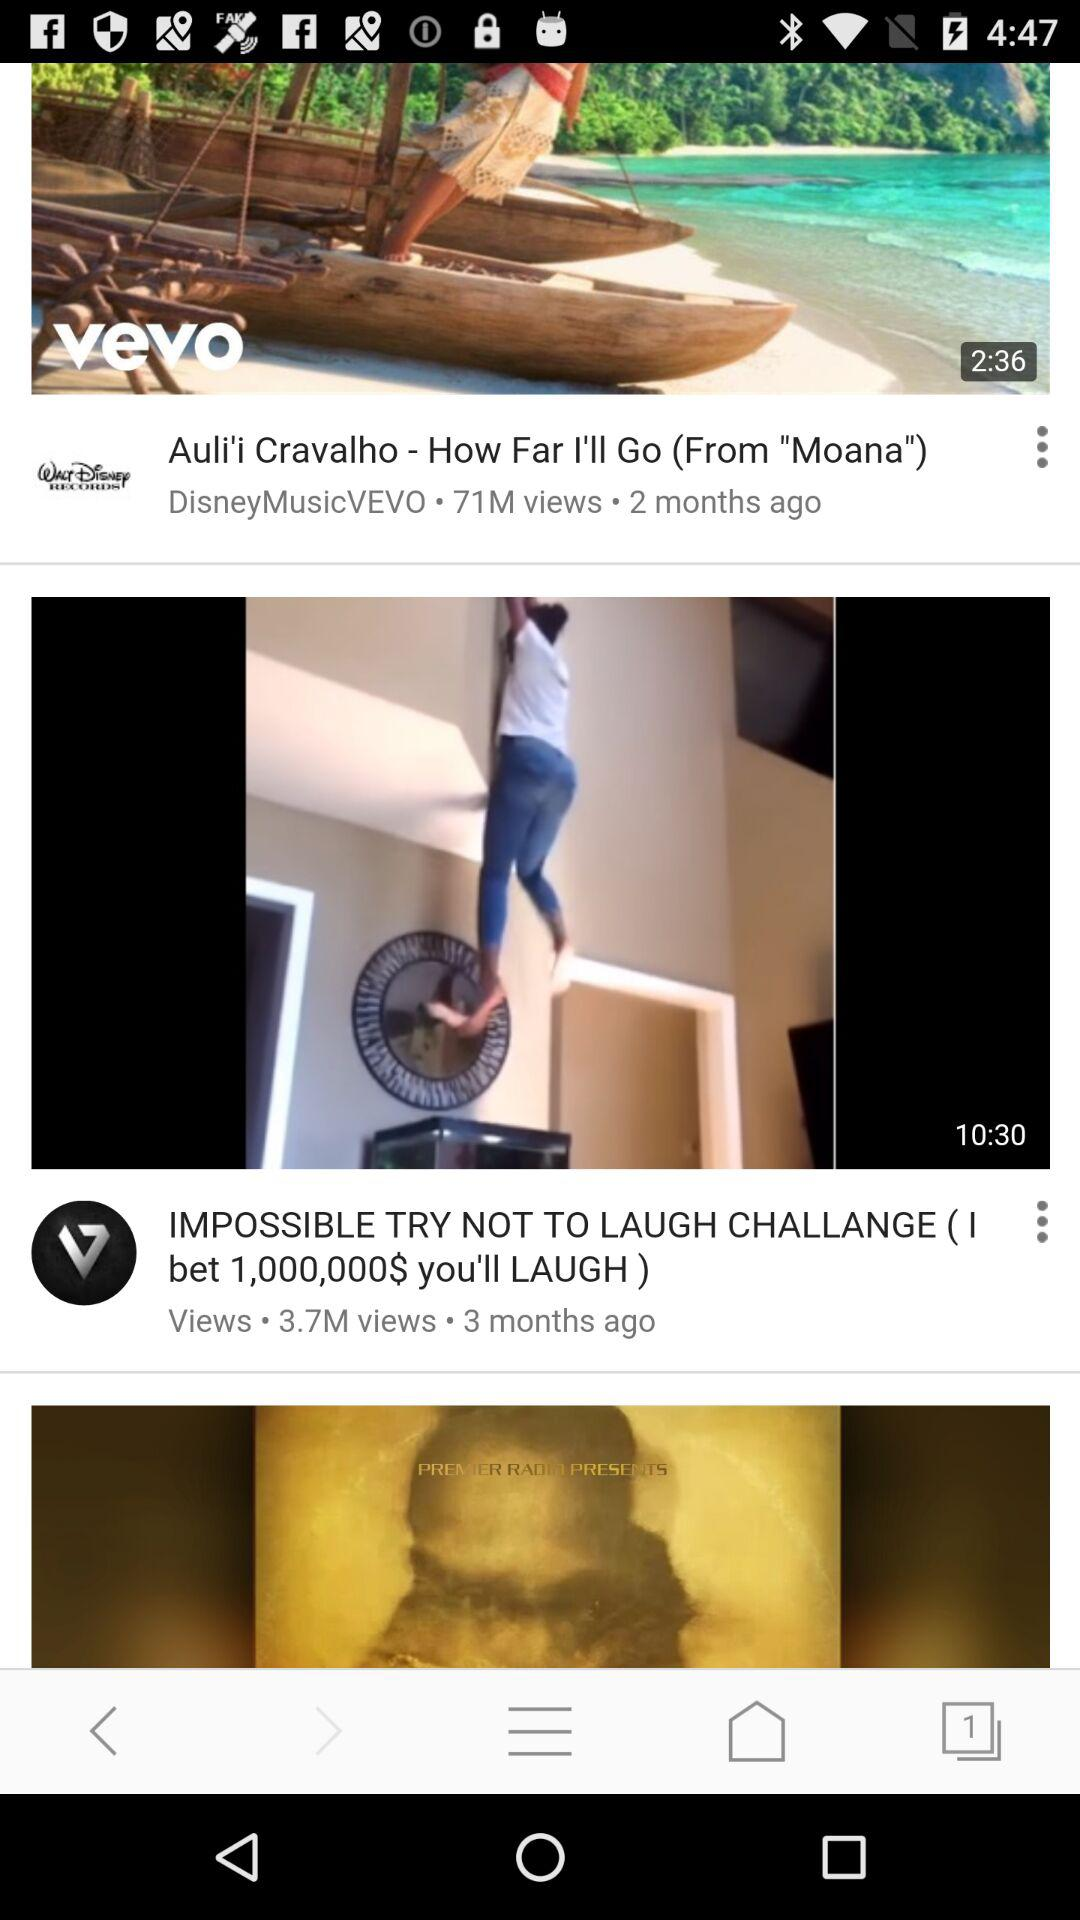When was "IMPOSSIBLE TRY NOT TO LAUGH CHALLANGE" posted? It was posted 3 months ago. 